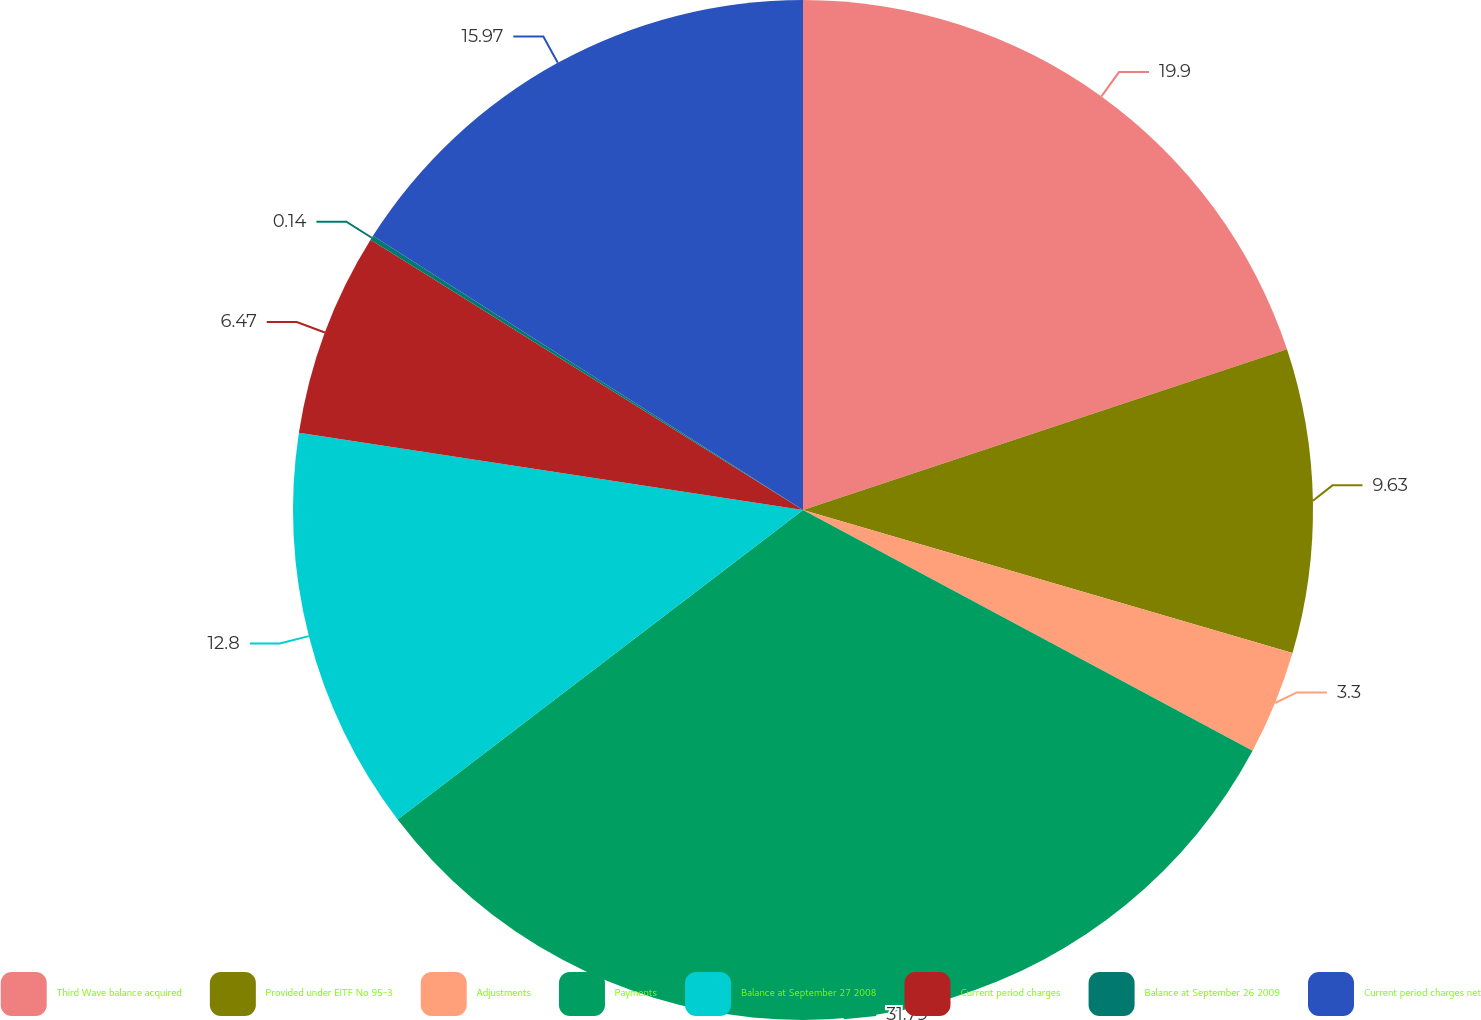<chart> <loc_0><loc_0><loc_500><loc_500><pie_chart><fcel>Third Wave balance acquired<fcel>Provided under EITF No 95-3<fcel>Adjustments<fcel>Payments<fcel>Balance at September 27 2008<fcel>Current period charges<fcel>Balance at September 26 2009<fcel>Current period charges net<nl><fcel>19.9%<fcel>9.63%<fcel>3.3%<fcel>31.8%<fcel>12.8%<fcel>6.47%<fcel>0.14%<fcel>15.97%<nl></chart> 